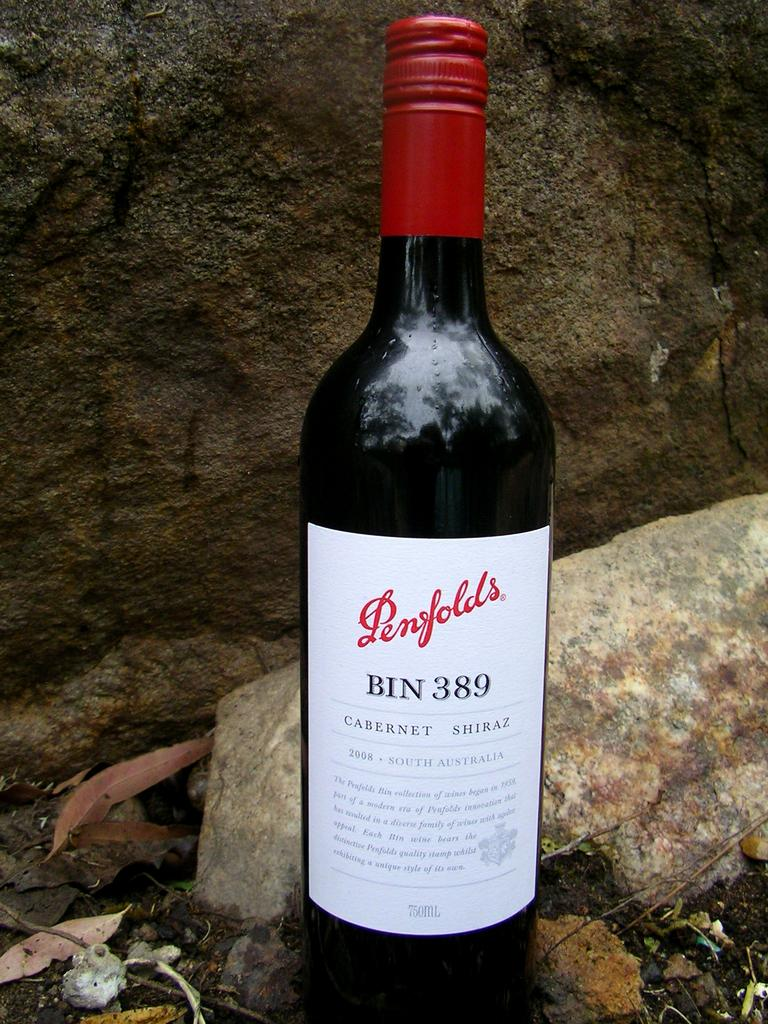Provide a one-sentence caption for the provided image. A bottle of Penfolds wine from South Australia. 